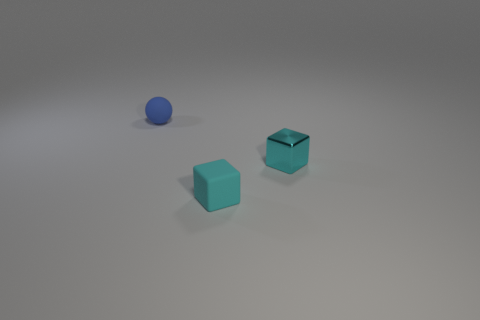Are there any objects of the same color as the matte cube?
Provide a short and direct response. Yes. Is the color of the matte block the same as the tiny ball?
Your answer should be compact. No. What material is the block that is the same color as the metallic object?
Your answer should be compact. Rubber. Do the tiny matte thing behind the small cyan matte object and the small thing to the right of the small cyan matte object have the same shape?
Your response must be concise. No. How many other objects are there of the same material as the blue ball?
Offer a very short reply. 1. Does the small thing in front of the shiny object have the same material as the small thing that is behind the shiny object?
Ensure brevity in your answer.  Yes. There is a small thing that is made of the same material as the small ball; what shape is it?
Offer a terse response. Cube. Are there any other things that are the same color as the matte sphere?
Offer a terse response. No. What number of tiny blue balls are there?
Your answer should be very brief. 1. There is a tiny thing that is both right of the blue sphere and behind the cyan matte block; what shape is it?
Offer a terse response. Cube. 